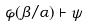<formula> <loc_0><loc_0><loc_500><loc_500>\varphi ( \beta / \alpha ) \vdash \psi</formula> 